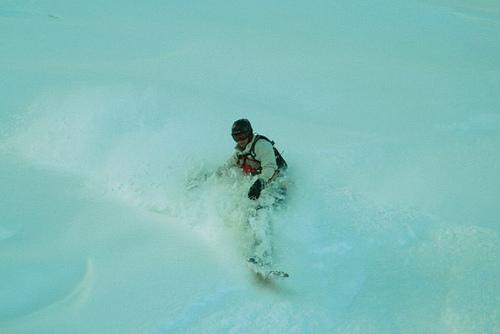Briefly describe the main action happening in the image and mention the attire of the subject. A snowboarder dressed in white and wearing a helmet and goggles is sliding down the snow-covered slope. Write a short statement about the main focal point in the image and the environment it is in. A snowboarder wearing protective gear is skillfully navigating a snow-covered mountain slope. Narrate the main activity taking place in the image and the person involved. A man clad in appropriate gear is snowboarding down a mountain, causing snow to kick up in the air around him. In one sentence, describe the primary subject and their activity in the image. A well-equipped snowboarder swiftly maneuvers down the snowy slope, leaving a trail of flying snow. Provide a comprehensive overview of the scene depicted in the image. A man snowboarding down a mountain wearing a helmet, goggles, white jacket, and gloves, surrounded by snow kicked up in the air. Write an expressive statement describing the major action and participant in the image. A daring snowboarder, donned in protective gear, tackles the mountain's snowy incline with finesse and speed. Provide a concise explanation of the scenario and the main subject portrayed in the image. The image depicts a snowboarder with a helmet, goggles, and gloves, speeding down the mountain as snow spurts around him. Compose a quick summary of the scene featured in the image. A snowboarder, outfitted in appropriate attire, swerves down the snowy slope, causing snow to fly up around him. Summarize the primary subject and their actions in the image. A snowboarder, equipped with safety gear, descends the mountain as snow kicks up around him. In a descriptive sentence, mention the key elements visible in the image. A snowboarder glides down the slope, wearing a helmet, goggles, and gloves, while snow flies around him. 